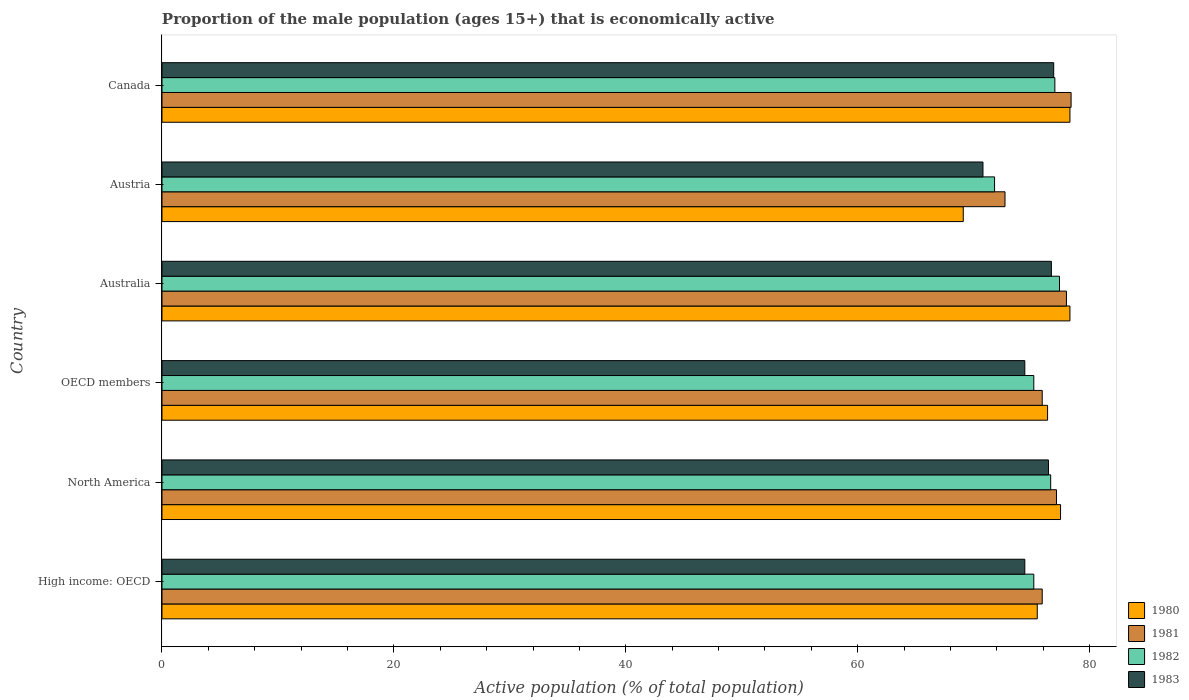How many bars are there on the 4th tick from the bottom?
Ensure brevity in your answer.  4. What is the proportion of the male population that is economically active in 1981 in Austria?
Provide a short and direct response. 72.7. Across all countries, what is the maximum proportion of the male population that is economically active in 1981?
Provide a succinct answer. 78.4. Across all countries, what is the minimum proportion of the male population that is economically active in 1981?
Give a very brief answer. 72.7. What is the total proportion of the male population that is economically active in 1982 in the graph?
Ensure brevity in your answer.  453.21. What is the difference between the proportion of the male population that is economically active in 1980 in High income: OECD and that in North America?
Provide a succinct answer. -2.01. What is the difference between the proportion of the male population that is economically active in 1980 in Austria and the proportion of the male population that is economically active in 1982 in North America?
Provide a succinct answer. -7.54. What is the average proportion of the male population that is economically active in 1980 per country?
Offer a terse response. 75.84. What is the difference between the proportion of the male population that is economically active in 1982 and proportion of the male population that is economically active in 1983 in Australia?
Your answer should be compact. 0.7. What is the ratio of the proportion of the male population that is economically active in 1981 in Canada to that in High income: OECD?
Give a very brief answer. 1.03. Is the proportion of the male population that is economically active in 1980 in Austria less than that in Canada?
Give a very brief answer. Yes. Is the difference between the proportion of the male population that is economically active in 1982 in High income: OECD and North America greater than the difference between the proportion of the male population that is economically active in 1983 in High income: OECD and North America?
Give a very brief answer. Yes. What is the difference between the highest and the second highest proportion of the male population that is economically active in 1983?
Give a very brief answer. 0.2. What is the difference between the highest and the lowest proportion of the male population that is economically active in 1983?
Your response must be concise. 6.1. Is it the case that in every country, the sum of the proportion of the male population that is economically active in 1983 and proportion of the male population that is economically active in 1982 is greater than the sum of proportion of the male population that is economically active in 1980 and proportion of the male population that is economically active in 1981?
Offer a very short reply. No. What does the 3rd bar from the top in Austria represents?
Your answer should be compact. 1981. What does the 3rd bar from the bottom in North America represents?
Your answer should be very brief. 1982. Is it the case that in every country, the sum of the proportion of the male population that is economically active in 1980 and proportion of the male population that is economically active in 1982 is greater than the proportion of the male population that is economically active in 1983?
Give a very brief answer. Yes. How many bars are there?
Your answer should be very brief. 24. Are the values on the major ticks of X-axis written in scientific E-notation?
Your answer should be very brief. No. What is the title of the graph?
Keep it short and to the point. Proportion of the male population (ages 15+) that is economically active. Does "1974" appear as one of the legend labels in the graph?
Offer a terse response. No. What is the label or title of the X-axis?
Keep it short and to the point. Active population (% of total population). What is the Active population (% of total population) of 1980 in High income: OECD?
Make the answer very short. 75.48. What is the Active population (% of total population) in 1981 in High income: OECD?
Your answer should be very brief. 75.91. What is the Active population (% of total population) in 1982 in High income: OECD?
Your answer should be compact. 75.18. What is the Active population (% of total population) in 1983 in High income: OECD?
Give a very brief answer. 74.41. What is the Active population (% of total population) of 1980 in North America?
Make the answer very short. 77.49. What is the Active population (% of total population) in 1981 in North America?
Keep it short and to the point. 77.14. What is the Active population (% of total population) in 1982 in North America?
Make the answer very short. 76.64. What is the Active population (% of total population) in 1983 in North America?
Keep it short and to the point. 76.45. What is the Active population (% of total population) of 1980 in OECD members?
Your answer should be compact. 76.37. What is the Active population (% of total population) in 1981 in OECD members?
Your response must be concise. 75.91. What is the Active population (% of total population) in 1982 in OECD members?
Your answer should be compact. 75.18. What is the Active population (% of total population) in 1983 in OECD members?
Your response must be concise. 74.41. What is the Active population (% of total population) of 1980 in Australia?
Your answer should be compact. 78.3. What is the Active population (% of total population) in 1981 in Australia?
Your answer should be very brief. 78. What is the Active population (% of total population) in 1982 in Australia?
Offer a very short reply. 77.4. What is the Active population (% of total population) of 1983 in Australia?
Offer a very short reply. 76.7. What is the Active population (% of total population) of 1980 in Austria?
Provide a short and direct response. 69.1. What is the Active population (% of total population) of 1981 in Austria?
Offer a terse response. 72.7. What is the Active population (% of total population) in 1982 in Austria?
Give a very brief answer. 71.8. What is the Active population (% of total population) in 1983 in Austria?
Your answer should be very brief. 70.8. What is the Active population (% of total population) in 1980 in Canada?
Keep it short and to the point. 78.3. What is the Active population (% of total population) in 1981 in Canada?
Provide a succinct answer. 78.4. What is the Active population (% of total population) of 1982 in Canada?
Your answer should be very brief. 77. What is the Active population (% of total population) of 1983 in Canada?
Offer a terse response. 76.9. Across all countries, what is the maximum Active population (% of total population) of 1980?
Keep it short and to the point. 78.3. Across all countries, what is the maximum Active population (% of total population) in 1981?
Your answer should be compact. 78.4. Across all countries, what is the maximum Active population (% of total population) in 1982?
Give a very brief answer. 77.4. Across all countries, what is the maximum Active population (% of total population) of 1983?
Offer a terse response. 76.9. Across all countries, what is the minimum Active population (% of total population) in 1980?
Provide a succinct answer. 69.1. Across all countries, what is the minimum Active population (% of total population) in 1981?
Offer a terse response. 72.7. Across all countries, what is the minimum Active population (% of total population) in 1982?
Ensure brevity in your answer.  71.8. Across all countries, what is the minimum Active population (% of total population) of 1983?
Ensure brevity in your answer.  70.8. What is the total Active population (% of total population) in 1980 in the graph?
Offer a very short reply. 455.04. What is the total Active population (% of total population) of 1981 in the graph?
Provide a succinct answer. 458.06. What is the total Active population (% of total population) in 1982 in the graph?
Make the answer very short. 453.21. What is the total Active population (% of total population) in 1983 in the graph?
Make the answer very short. 449.67. What is the difference between the Active population (% of total population) in 1980 in High income: OECD and that in North America?
Your answer should be very brief. -2.01. What is the difference between the Active population (% of total population) in 1981 in High income: OECD and that in North America?
Provide a succinct answer. -1.23. What is the difference between the Active population (% of total population) in 1982 in High income: OECD and that in North America?
Ensure brevity in your answer.  -1.46. What is the difference between the Active population (% of total population) of 1983 in High income: OECD and that in North America?
Your response must be concise. -2.04. What is the difference between the Active population (% of total population) of 1980 in High income: OECD and that in OECD members?
Make the answer very short. -0.89. What is the difference between the Active population (% of total population) of 1980 in High income: OECD and that in Australia?
Provide a short and direct response. -2.82. What is the difference between the Active population (% of total population) of 1981 in High income: OECD and that in Australia?
Your answer should be compact. -2.09. What is the difference between the Active population (% of total population) of 1982 in High income: OECD and that in Australia?
Provide a succinct answer. -2.22. What is the difference between the Active population (% of total population) of 1983 in High income: OECD and that in Australia?
Your answer should be very brief. -2.29. What is the difference between the Active population (% of total population) in 1980 in High income: OECD and that in Austria?
Your response must be concise. 6.38. What is the difference between the Active population (% of total population) in 1981 in High income: OECD and that in Austria?
Keep it short and to the point. 3.21. What is the difference between the Active population (% of total population) in 1982 in High income: OECD and that in Austria?
Give a very brief answer. 3.38. What is the difference between the Active population (% of total population) of 1983 in High income: OECD and that in Austria?
Ensure brevity in your answer.  3.61. What is the difference between the Active population (% of total population) in 1980 in High income: OECD and that in Canada?
Your answer should be very brief. -2.82. What is the difference between the Active population (% of total population) of 1981 in High income: OECD and that in Canada?
Make the answer very short. -2.49. What is the difference between the Active population (% of total population) of 1982 in High income: OECD and that in Canada?
Provide a succinct answer. -1.82. What is the difference between the Active population (% of total population) of 1983 in High income: OECD and that in Canada?
Keep it short and to the point. -2.49. What is the difference between the Active population (% of total population) in 1980 in North America and that in OECD members?
Give a very brief answer. 1.12. What is the difference between the Active population (% of total population) in 1981 in North America and that in OECD members?
Provide a short and direct response. 1.23. What is the difference between the Active population (% of total population) in 1982 in North America and that in OECD members?
Ensure brevity in your answer.  1.46. What is the difference between the Active population (% of total population) of 1983 in North America and that in OECD members?
Give a very brief answer. 2.04. What is the difference between the Active population (% of total population) of 1980 in North America and that in Australia?
Your response must be concise. -0.81. What is the difference between the Active population (% of total population) in 1981 in North America and that in Australia?
Provide a short and direct response. -0.86. What is the difference between the Active population (% of total population) in 1982 in North America and that in Australia?
Provide a succinct answer. -0.76. What is the difference between the Active population (% of total population) of 1983 in North America and that in Australia?
Provide a succinct answer. -0.25. What is the difference between the Active population (% of total population) of 1980 in North America and that in Austria?
Offer a very short reply. 8.39. What is the difference between the Active population (% of total population) of 1981 in North America and that in Austria?
Ensure brevity in your answer.  4.44. What is the difference between the Active population (% of total population) of 1982 in North America and that in Austria?
Your response must be concise. 4.84. What is the difference between the Active population (% of total population) in 1983 in North America and that in Austria?
Give a very brief answer. 5.65. What is the difference between the Active population (% of total population) of 1980 in North America and that in Canada?
Make the answer very short. -0.81. What is the difference between the Active population (% of total population) of 1981 in North America and that in Canada?
Ensure brevity in your answer.  -1.26. What is the difference between the Active population (% of total population) in 1982 in North America and that in Canada?
Your response must be concise. -0.36. What is the difference between the Active population (% of total population) of 1983 in North America and that in Canada?
Your response must be concise. -0.45. What is the difference between the Active population (% of total population) in 1980 in OECD members and that in Australia?
Offer a terse response. -1.93. What is the difference between the Active population (% of total population) of 1981 in OECD members and that in Australia?
Keep it short and to the point. -2.09. What is the difference between the Active population (% of total population) in 1982 in OECD members and that in Australia?
Give a very brief answer. -2.22. What is the difference between the Active population (% of total population) in 1983 in OECD members and that in Australia?
Your answer should be compact. -2.29. What is the difference between the Active population (% of total population) of 1980 in OECD members and that in Austria?
Give a very brief answer. 7.27. What is the difference between the Active population (% of total population) of 1981 in OECD members and that in Austria?
Make the answer very short. 3.21. What is the difference between the Active population (% of total population) in 1982 in OECD members and that in Austria?
Your response must be concise. 3.38. What is the difference between the Active population (% of total population) in 1983 in OECD members and that in Austria?
Keep it short and to the point. 3.61. What is the difference between the Active population (% of total population) in 1980 in OECD members and that in Canada?
Your response must be concise. -1.93. What is the difference between the Active population (% of total population) in 1981 in OECD members and that in Canada?
Your response must be concise. -2.49. What is the difference between the Active population (% of total population) of 1982 in OECD members and that in Canada?
Offer a terse response. -1.82. What is the difference between the Active population (% of total population) in 1983 in OECD members and that in Canada?
Offer a terse response. -2.49. What is the difference between the Active population (% of total population) of 1981 in Australia and that in Austria?
Provide a succinct answer. 5.3. What is the difference between the Active population (% of total population) of 1983 in Australia and that in Austria?
Offer a terse response. 5.9. What is the difference between the Active population (% of total population) of 1981 in Australia and that in Canada?
Give a very brief answer. -0.4. What is the difference between the Active population (% of total population) in 1983 in Australia and that in Canada?
Make the answer very short. -0.2. What is the difference between the Active population (% of total population) in 1980 in High income: OECD and the Active population (% of total population) in 1981 in North America?
Your answer should be very brief. -1.66. What is the difference between the Active population (% of total population) of 1980 in High income: OECD and the Active population (% of total population) of 1982 in North America?
Offer a terse response. -1.16. What is the difference between the Active population (% of total population) in 1980 in High income: OECD and the Active population (% of total population) in 1983 in North America?
Give a very brief answer. -0.97. What is the difference between the Active population (% of total population) in 1981 in High income: OECD and the Active population (% of total population) in 1982 in North America?
Keep it short and to the point. -0.73. What is the difference between the Active population (% of total population) of 1981 in High income: OECD and the Active population (% of total population) of 1983 in North America?
Keep it short and to the point. -0.54. What is the difference between the Active population (% of total population) in 1982 in High income: OECD and the Active population (% of total population) in 1983 in North America?
Your answer should be compact. -1.27. What is the difference between the Active population (% of total population) in 1980 in High income: OECD and the Active population (% of total population) in 1981 in OECD members?
Offer a terse response. -0.43. What is the difference between the Active population (% of total population) of 1980 in High income: OECD and the Active population (% of total population) of 1982 in OECD members?
Ensure brevity in your answer.  0.3. What is the difference between the Active population (% of total population) in 1980 in High income: OECD and the Active population (% of total population) in 1983 in OECD members?
Your answer should be very brief. 1.07. What is the difference between the Active population (% of total population) of 1981 in High income: OECD and the Active population (% of total population) of 1982 in OECD members?
Provide a succinct answer. 0.73. What is the difference between the Active population (% of total population) in 1981 in High income: OECD and the Active population (% of total population) in 1983 in OECD members?
Your answer should be compact. 1.5. What is the difference between the Active population (% of total population) of 1982 in High income: OECD and the Active population (% of total population) of 1983 in OECD members?
Your answer should be compact. 0.77. What is the difference between the Active population (% of total population) in 1980 in High income: OECD and the Active population (% of total population) in 1981 in Australia?
Your answer should be very brief. -2.52. What is the difference between the Active population (% of total population) of 1980 in High income: OECD and the Active population (% of total population) of 1982 in Australia?
Make the answer very short. -1.92. What is the difference between the Active population (% of total population) in 1980 in High income: OECD and the Active population (% of total population) in 1983 in Australia?
Offer a terse response. -1.22. What is the difference between the Active population (% of total population) of 1981 in High income: OECD and the Active population (% of total population) of 1982 in Australia?
Provide a short and direct response. -1.49. What is the difference between the Active population (% of total population) of 1981 in High income: OECD and the Active population (% of total population) of 1983 in Australia?
Provide a succinct answer. -0.79. What is the difference between the Active population (% of total population) of 1982 in High income: OECD and the Active population (% of total population) of 1983 in Australia?
Keep it short and to the point. -1.52. What is the difference between the Active population (% of total population) in 1980 in High income: OECD and the Active population (% of total population) in 1981 in Austria?
Your response must be concise. 2.78. What is the difference between the Active population (% of total population) in 1980 in High income: OECD and the Active population (% of total population) in 1982 in Austria?
Your answer should be very brief. 3.68. What is the difference between the Active population (% of total population) in 1980 in High income: OECD and the Active population (% of total population) in 1983 in Austria?
Keep it short and to the point. 4.68. What is the difference between the Active population (% of total population) in 1981 in High income: OECD and the Active population (% of total population) in 1982 in Austria?
Your answer should be compact. 4.11. What is the difference between the Active population (% of total population) of 1981 in High income: OECD and the Active population (% of total population) of 1983 in Austria?
Provide a short and direct response. 5.11. What is the difference between the Active population (% of total population) of 1982 in High income: OECD and the Active population (% of total population) of 1983 in Austria?
Keep it short and to the point. 4.38. What is the difference between the Active population (% of total population) of 1980 in High income: OECD and the Active population (% of total population) of 1981 in Canada?
Your response must be concise. -2.92. What is the difference between the Active population (% of total population) in 1980 in High income: OECD and the Active population (% of total population) in 1982 in Canada?
Ensure brevity in your answer.  -1.52. What is the difference between the Active population (% of total population) in 1980 in High income: OECD and the Active population (% of total population) in 1983 in Canada?
Your answer should be very brief. -1.42. What is the difference between the Active population (% of total population) of 1981 in High income: OECD and the Active population (% of total population) of 1982 in Canada?
Your response must be concise. -1.09. What is the difference between the Active population (% of total population) in 1981 in High income: OECD and the Active population (% of total population) in 1983 in Canada?
Your answer should be very brief. -0.99. What is the difference between the Active population (% of total population) in 1982 in High income: OECD and the Active population (% of total population) in 1983 in Canada?
Provide a succinct answer. -1.72. What is the difference between the Active population (% of total population) of 1980 in North America and the Active population (% of total population) of 1981 in OECD members?
Ensure brevity in your answer.  1.58. What is the difference between the Active population (% of total population) in 1980 in North America and the Active population (% of total population) in 1982 in OECD members?
Offer a very short reply. 2.31. What is the difference between the Active population (% of total population) of 1980 in North America and the Active population (% of total population) of 1983 in OECD members?
Keep it short and to the point. 3.08. What is the difference between the Active population (% of total population) of 1981 in North America and the Active population (% of total population) of 1982 in OECD members?
Ensure brevity in your answer.  1.96. What is the difference between the Active population (% of total population) in 1981 in North America and the Active population (% of total population) in 1983 in OECD members?
Provide a succinct answer. 2.73. What is the difference between the Active population (% of total population) in 1982 in North America and the Active population (% of total population) in 1983 in OECD members?
Your response must be concise. 2.23. What is the difference between the Active population (% of total population) of 1980 in North America and the Active population (% of total population) of 1981 in Australia?
Your response must be concise. -0.51. What is the difference between the Active population (% of total population) in 1980 in North America and the Active population (% of total population) in 1982 in Australia?
Give a very brief answer. 0.09. What is the difference between the Active population (% of total population) of 1980 in North America and the Active population (% of total population) of 1983 in Australia?
Your answer should be compact. 0.79. What is the difference between the Active population (% of total population) of 1981 in North America and the Active population (% of total population) of 1982 in Australia?
Give a very brief answer. -0.26. What is the difference between the Active population (% of total population) in 1981 in North America and the Active population (% of total population) in 1983 in Australia?
Make the answer very short. 0.44. What is the difference between the Active population (% of total population) in 1982 in North America and the Active population (% of total population) in 1983 in Australia?
Provide a short and direct response. -0.06. What is the difference between the Active population (% of total population) of 1980 in North America and the Active population (% of total population) of 1981 in Austria?
Offer a terse response. 4.79. What is the difference between the Active population (% of total population) in 1980 in North America and the Active population (% of total population) in 1982 in Austria?
Offer a terse response. 5.69. What is the difference between the Active population (% of total population) in 1980 in North America and the Active population (% of total population) in 1983 in Austria?
Provide a succinct answer. 6.69. What is the difference between the Active population (% of total population) in 1981 in North America and the Active population (% of total population) in 1982 in Austria?
Offer a terse response. 5.34. What is the difference between the Active population (% of total population) of 1981 in North America and the Active population (% of total population) of 1983 in Austria?
Provide a succinct answer. 6.34. What is the difference between the Active population (% of total population) of 1982 in North America and the Active population (% of total population) of 1983 in Austria?
Keep it short and to the point. 5.84. What is the difference between the Active population (% of total population) in 1980 in North America and the Active population (% of total population) in 1981 in Canada?
Provide a succinct answer. -0.91. What is the difference between the Active population (% of total population) in 1980 in North America and the Active population (% of total population) in 1982 in Canada?
Offer a terse response. 0.49. What is the difference between the Active population (% of total population) in 1980 in North America and the Active population (% of total population) in 1983 in Canada?
Provide a short and direct response. 0.59. What is the difference between the Active population (% of total population) of 1981 in North America and the Active population (% of total population) of 1982 in Canada?
Offer a very short reply. 0.14. What is the difference between the Active population (% of total population) of 1981 in North America and the Active population (% of total population) of 1983 in Canada?
Give a very brief answer. 0.24. What is the difference between the Active population (% of total population) in 1982 in North America and the Active population (% of total population) in 1983 in Canada?
Make the answer very short. -0.26. What is the difference between the Active population (% of total population) in 1980 in OECD members and the Active population (% of total population) in 1981 in Australia?
Keep it short and to the point. -1.63. What is the difference between the Active population (% of total population) of 1980 in OECD members and the Active population (% of total population) of 1982 in Australia?
Offer a very short reply. -1.03. What is the difference between the Active population (% of total population) in 1980 in OECD members and the Active population (% of total population) in 1983 in Australia?
Provide a succinct answer. -0.33. What is the difference between the Active population (% of total population) in 1981 in OECD members and the Active population (% of total population) in 1982 in Australia?
Your answer should be very brief. -1.49. What is the difference between the Active population (% of total population) of 1981 in OECD members and the Active population (% of total population) of 1983 in Australia?
Provide a succinct answer. -0.79. What is the difference between the Active population (% of total population) in 1982 in OECD members and the Active population (% of total population) in 1983 in Australia?
Your response must be concise. -1.52. What is the difference between the Active population (% of total population) in 1980 in OECD members and the Active population (% of total population) in 1981 in Austria?
Your answer should be compact. 3.67. What is the difference between the Active population (% of total population) of 1980 in OECD members and the Active population (% of total population) of 1982 in Austria?
Your answer should be compact. 4.57. What is the difference between the Active population (% of total population) of 1980 in OECD members and the Active population (% of total population) of 1983 in Austria?
Provide a short and direct response. 5.57. What is the difference between the Active population (% of total population) of 1981 in OECD members and the Active population (% of total population) of 1982 in Austria?
Your answer should be compact. 4.11. What is the difference between the Active population (% of total population) in 1981 in OECD members and the Active population (% of total population) in 1983 in Austria?
Your answer should be compact. 5.11. What is the difference between the Active population (% of total population) of 1982 in OECD members and the Active population (% of total population) of 1983 in Austria?
Ensure brevity in your answer.  4.38. What is the difference between the Active population (% of total population) in 1980 in OECD members and the Active population (% of total population) in 1981 in Canada?
Make the answer very short. -2.03. What is the difference between the Active population (% of total population) of 1980 in OECD members and the Active population (% of total population) of 1982 in Canada?
Offer a very short reply. -0.63. What is the difference between the Active population (% of total population) of 1980 in OECD members and the Active population (% of total population) of 1983 in Canada?
Ensure brevity in your answer.  -0.53. What is the difference between the Active population (% of total population) in 1981 in OECD members and the Active population (% of total population) in 1982 in Canada?
Ensure brevity in your answer.  -1.09. What is the difference between the Active population (% of total population) in 1981 in OECD members and the Active population (% of total population) in 1983 in Canada?
Ensure brevity in your answer.  -0.99. What is the difference between the Active population (% of total population) in 1982 in OECD members and the Active population (% of total population) in 1983 in Canada?
Keep it short and to the point. -1.72. What is the difference between the Active population (% of total population) of 1980 in Australia and the Active population (% of total population) of 1981 in Austria?
Offer a very short reply. 5.6. What is the difference between the Active population (% of total population) of 1980 in Australia and the Active population (% of total population) of 1982 in Austria?
Offer a very short reply. 6.5. What is the difference between the Active population (% of total population) in 1980 in Australia and the Active population (% of total population) in 1983 in Austria?
Make the answer very short. 7.5. What is the difference between the Active population (% of total population) of 1981 in Australia and the Active population (% of total population) of 1982 in Austria?
Make the answer very short. 6.2. What is the difference between the Active population (% of total population) in 1980 in Australia and the Active population (% of total population) in 1981 in Canada?
Your response must be concise. -0.1. What is the difference between the Active population (% of total population) in 1981 in Australia and the Active population (% of total population) in 1982 in Canada?
Offer a very short reply. 1. What is the difference between the Active population (% of total population) in 1982 in Australia and the Active population (% of total population) in 1983 in Canada?
Make the answer very short. 0.5. What is the difference between the Active population (% of total population) in 1980 in Austria and the Active population (% of total population) in 1982 in Canada?
Your answer should be very brief. -7.9. What is the difference between the Active population (% of total population) in 1980 in Austria and the Active population (% of total population) in 1983 in Canada?
Give a very brief answer. -7.8. What is the difference between the Active population (% of total population) of 1981 in Austria and the Active population (% of total population) of 1982 in Canada?
Your answer should be compact. -4.3. What is the difference between the Active population (% of total population) of 1982 in Austria and the Active population (% of total population) of 1983 in Canada?
Your answer should be compact. -5.1. What is the average Active population (% of total population) in 1980 per country?
Provide a succinct answer. 75.84. What is the average Active population (% of total population) of 1981 per country?
Make the answer very short. 76.34. What is the average Active population (% of total population) of 1982 per country?
Keep it short and to the point. 75.53. What is the average Active population (% of total population) in 1983 per country?
Make the answer very short. 74.94. What is the difference between the Active population (% of total population) in 1980 and Active population (% of total population) in 1981 in High income: OECD?
Make the answer very short. -0.43. What is the difference between the Active population (% of total population) of 1980 and Active population (% of total population) of 1982 in High income: OECD?
Provide a short and direct response. 0.3. What is the difference between the Active population (% of total population) of 1980 and Active population (% of total population) of 1983 in High income: OECD?
Give a very brief answer. 1.07. What is the difference between the Active population (% of total population) of 1981 and Active population (% of total population) of 1982 in High income: OECD?
Your answer should be compact. 0.73. What is the difference between the Active population (% of total population) of 1981 and Active population (% of total population) of 1983 in High income: OECD?
Offer a very short reply. 1.5. What is the difference between the Active population (% of total population) of 1982 and Active population (% of total population) of 1983 in High income: OECD?
Make the answer very short. 0.77. What is the difference between the Active population (% of total population) in 1980 and Active population (% of total population) in 1981 in North America?
Your response must be concise. 0.35. What is the difference between the Active population (% of total population) of 1980 and Active population (% of total population) of 1982 in North America?
Ensure brevity in your answer.  0.85. What is the difference between the Active population (% of total population) in 1980 and Active population (% of total population) in 1983 in North America?
Your response must be concise. 1.04. What is the difference between the Active population (% of total population) of 1981 and Active population (% of total population) of 1982 in North America?
Offer a very short reply. 0.5. What is the difference between the Active population (% of total population) in 1981 and Active population (% of total population) in 1983 in North America?
Make the answer very short. 0.69. What is the difference between the Active population (% of total population) in 1982 and Active population (% of total population) in 1983 in North America?
Your answer should be very brief. 0.19. What is the difference between the Active population (% of total population) in 1980 and Active population (% of total population) in 1981 in OECD members?
Give a very brief answer. 0.46. What is the difference between the Active population (% of total population) of 1980 and Active population (% of total population) of 1982 in OECD members?
Your answer should be compact. 1.19. What is the difference between the Active population (% of total population) in 1980 and Active population (% of total population) in 1983 in OECD members?
Keep it short and to the point. 1.96. What is the difference between the Active population (% of total population) in 1981 and Active population (% of total population) in 1982 in OECD members?
Your answer should be very brief. 0.73. What is the difference between the Active population (% of total population) in 1981 and Active population (% of total population) in 1983 in OECD members?
Give a very brief answer. 1.5. What is the difference between the Active population (% of total population) of 1982 and Active population (% of total population) of 1983 in OECD members?
Offer a very short reply. 0.77. What is the difference between the Active population (% of total population) of 1980 and Active population (% of total population) of 1982 in Australia?
Give a very brief answer. 0.9. What is the difference between the Active population (% of total population) of 1980 and Active population (% of total population) of 1983 in Australia?
Your response must be concise. 1.6. What is the difference between the Active population (% of total population) in 1981 and Active population (% of total population) in 1982 in Australia?
Keep it short and to the point. 0.6. What is the difference between the Active population (% of total population) in 1981 and Active population (% of total population) in 1983 in Australia?
Make the answer very short. 1.3. What is the difference between the Active population (% of total population) of 1982 and Active population (% of total population) of 1983 in Australia?
Ensure brevity in your answer.  0.7. What is the difference between the Active population (% of total population) in 1980 and Active population (% of total population) in 1981 in Austria?
Provide a succinct answer. -3.6. What is the difference between the Active population (% of total population) of 1980 and Active population (% of total population) of 1983 in Austria?
Your response must be concise. -1.7. What is the difference between the Active population (% of total population) in 1981 and Active population (% of total population) in 1982 in Austria?
Keep it short and to the point. 0.9. What is the difference between the Active population (% of total population) in 1981 and Active population (% of total population) in 1983 in Austria?
Provide a succinct answer. 1.9. What is the difference between the Active population (% of total population) in 1980 and Active population (% of total population) in 1982 in Canada?
Ensure brevity in your answer.  1.3. What is the difference between the Active population (% of total population) in 1981 and Active population (% of total population) in 1983 in Canada?
Your answer should be compact. 1.5. What is the difference between the Active population (% of total population) of 1982 and Active population (% of total population) of 1983 in Canada?
Give a very brief answer. 0.1. What is the ratio of the Active population (% of total population) of 1980 in High income: OECD to that in North America?
Provide a succinct answer. 0.97. What is the ratio of the Active population (% of total population) in 1981 in High income: OECD to that in North America?
Give a very brief answer. 0.98. What is the ratio of the Active population (% of total population) in 1982 in High income: OECD to that in North America?
Your response must be concise. 0.98. What is the ratio of the Active population (% of total population) of 1983 in High income: OECD to that in North America?
Ensure brevity in your answer.  0.97. What is the ratio of the Active population (% of total population) of 1980 in High income: OECD to that in OECD members?
Ensure brevity in your answer.  0.99. What is the ratio of the Active population (% of total population) in 1981 in High income: OECD to that in Australia?
Keep it short and to the point. 0.97. What is the ratio of the Active population (% of total population) in 1982 in High income: OECD to that in Australia?
Make the answer very short. 0.97. What is the ratio of the Active population (% of total population) in 1983 in High income: OECD to that in Australia?
Make the answer very short. 0.97. What is the ratio of the Active population (% of total population) in 1980 in High income: OECD to that in Austria?
Offer a terse response. 1.09. What is the ratio of the Active population (% of total population) of 1981 in High income: OECD to that in Austria?
Offer a terse response. 1.04. What is the ratio of the Active population (% of total population) of 1982 in High income: OECD to that in Austria?
Offer a terse response. 1.05. What is the ratio of the Active population (% of total population) in 1983 in High income: OECD to that in Austria?
Give a very brief answer. 1.05. What is the ratio of the Active population (% of total population) of 1981 in High income: OECD to that in Canada?
Give a very brief answer. 0.97. What is the ratio of the Active population (% of total population) in 1982 in High income: OECD to that in Canada?
Give a very brief answer. 0.98. What is the ratio of the Active population (% of total population) of 1983 in High income: OECD to that in Canada?
Keep it short and to the point. 0.97. What is the ratio of the Active population (% of total population) in 1980 in North America to that in OECD members?
Your answer should be very brief. 1.01. What is the ratio of the Active population (% of total population) of 1981 in North America to that in OECD members?
Offer a terse response. 1.02. What is the ratio of the Active population (% of total population) of 1982 in North America to that in OECD members?
Give a very brief answer. 1.02. What is the ratio of the Active population (% of total population) of 1983 in North America to that in OECD members?
Your answer should be compact. 1.03. What is the ratio of the Active population (% of total population) of 1982 in North America to that in Australia?
Provide a short and direct response. 0.99. What is the ratio of the Active population (% of total population) in 1980 in North America to that in Austria?
Provide a succinct answer. 1.12. What is the ratio of the Active population (% of total population) of 1981 in North America to that in Austria?
Your response must be concise. 1.06. What is the ratio of the Active population (% of total population) of 1982 in North America to that in Austria?
Provide a short and direct response. 1.07. What is the ratio of the Active population (% of total population) of 1983 in North America to that in Austria?
Your response must be concise. 1.08. What is the ratio of the Active population (% of total population) in 1981 in North America to that in Canada?
Provide a succinct answer. 0.98. What is the ratio of the Active population (% of total population) of 1980 in OECD members to that in Australia?
Your answer should be compact. 0.98. What is the ratio of the Active population (% of total population) of 1981 in OECD members to that in Australia?
Offer a terse response. 0.97. What is the ratio of the Active population (% of total population) in 1982 in OECD members to that in Australia?
Give a very brief answer. 0.97. What is the ratio of the Active population (% of total population) in 1983 in OECD members to that in Australia?
Offer a very short reply. 0.97. What is the ratio of the Active population (% of total population) in 1980 in OECD members to that in Austria?
Ensure brevity in your answer.  1.11. What is the ratio of the Active population (% of total population) in 1981 in OECD members to that in Austria?
Provide a succinct answer. 1.04. What is the ratio of the Active population (% of total population) in 1982 in OECD members to that in Austria?
Keep it short and to the point. 1.05. What is the ratio of the Active population (% of total population) of 1983 in OECD members to that in Austria?
Make the answer very short. 1.05. What is the ratio of the Active population (% of total population) in 1980 in OECD members to that in Canada?
Offer a terse response. 0.98. What is the ratio of the Active population (% of total population) in 1981 in OECD members to that in Canada?
Your answer should be compact. 0.97. What is the ratio of the Active population (% of total population) of 1982 in OECD members to that in Canada?
Your response must be concise. 0.98. What is the ratio of the Active population (% of total population) of 1983 in OECD members to that in Canada?
Provide a short and direct response. 0.97. What is the ratio of the Active population (% of total population) in 1980 in Australia to that in Austria?
Offer a very short reply. 1.13. What is the ratio of the Active population (% of total population) in 1981 in Australia to that in Austria?
Your response must be concise. 1.07. What is the ratio of the Active population (% of total population) of 1982 in Australia to that in Austria?
Offer a terse response. 1.08. What is the ratio of the Active population (% of total population) of 1983 in Australia to that in Austria?
Provide a succinct answer. 1.08. What is the ratio of the Active population (% of total population) of 1980 in Australia to that in Canada?
Offer a terse response. 1. What is the ratio of the Active population (% of total population) of 1981 in Australia to that in Canada?
Offer a very short reply. 0.99. What is the ratio of the Active population (% of total population) in 1982 in Australia to that in Canada?
Make the answer very short. 1.01. What is the ratio of the Active population (% of total population) of 1983 in Australia to that in Canada?
Your answer should be compact. 1. What is the ratio of the Active population (% of total population) in 1980 in Austria to that in Canada?
Offer a very short reply. 0.88. What is the ratio of the Active population (% of total population) of 1981 in Austria to that in Canada?
Your answer should be compact. 0.93. What is the ratio of the Active population (% of total population) of 1982 in Austria to that in Canada?
Provide a short and direct response. 0.93. What is the ratio of the Active population (% of total population) in 1983 in Austria to that in Canada?
Your response must be concise. 0.92. What is the difference between the highest and the second highest Active population (% of total population) in 1980?
Make the answer very short. 0. What is the difference between the highest and the second highest Active population (% of total population) of 1981?
Provide a short and direct response. 0.4. What is the difference between the highest and the second highest Active population (% of total population) in 1983?
Ensure brevity in your answer.  0.2. What is the difference between the highest and the lowest Active population (% of total population) in 1980?
Provide a succinct answer. 9.2. What is the difference between the highest and the lowest Active population (% of total population) of 1981?
Give a very brief answer. 5.7. What is the difference between the highest and the lowest Active population (% of total population) in 1983?
Your response must be concise. 6.1. 